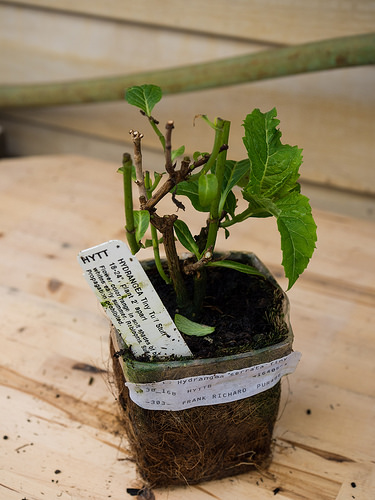<image>
Is there a plant on the pot? Yes. Looking at the image, I can see the plant is positioned on top of the pot, with the pot providing support. Is the table under the vase? Yes. The table is positioned underneath the vase, with the vase above it in the vertical space. 